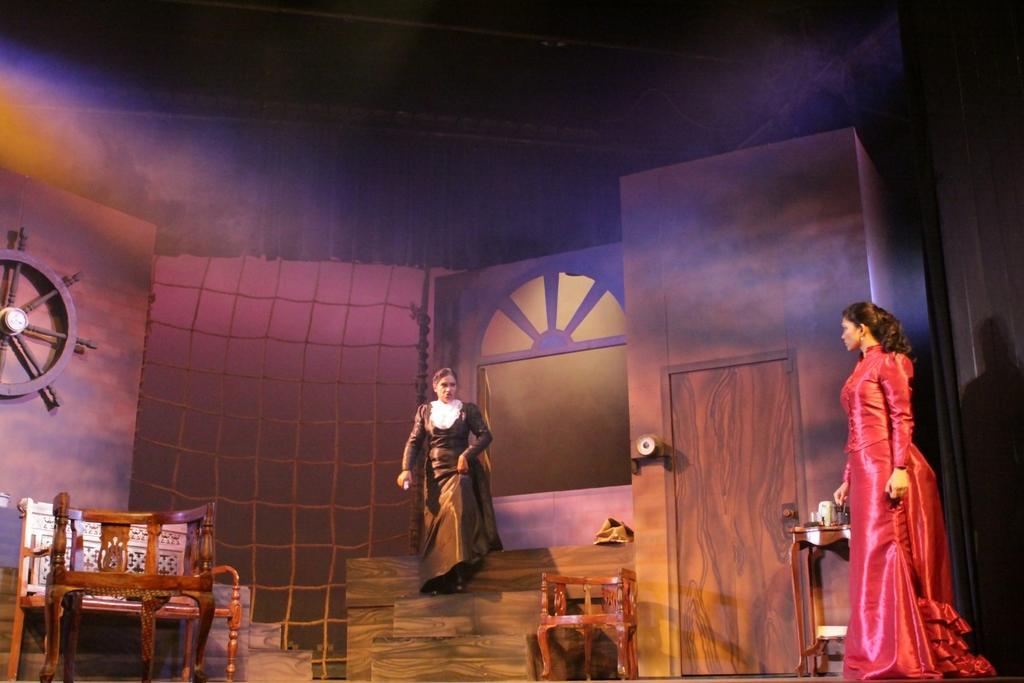Please provide a concise description of this image. In this image, I can see a woman with the red dress is stunning. These are the chairs. I can see a small table with few objects on it. This is the wooden door with the door handle. I can see another woman stepping down the stairs. This looks like a net. I can see a wooden wheel attached to the wall. I think these two women are doing a roleplay. 